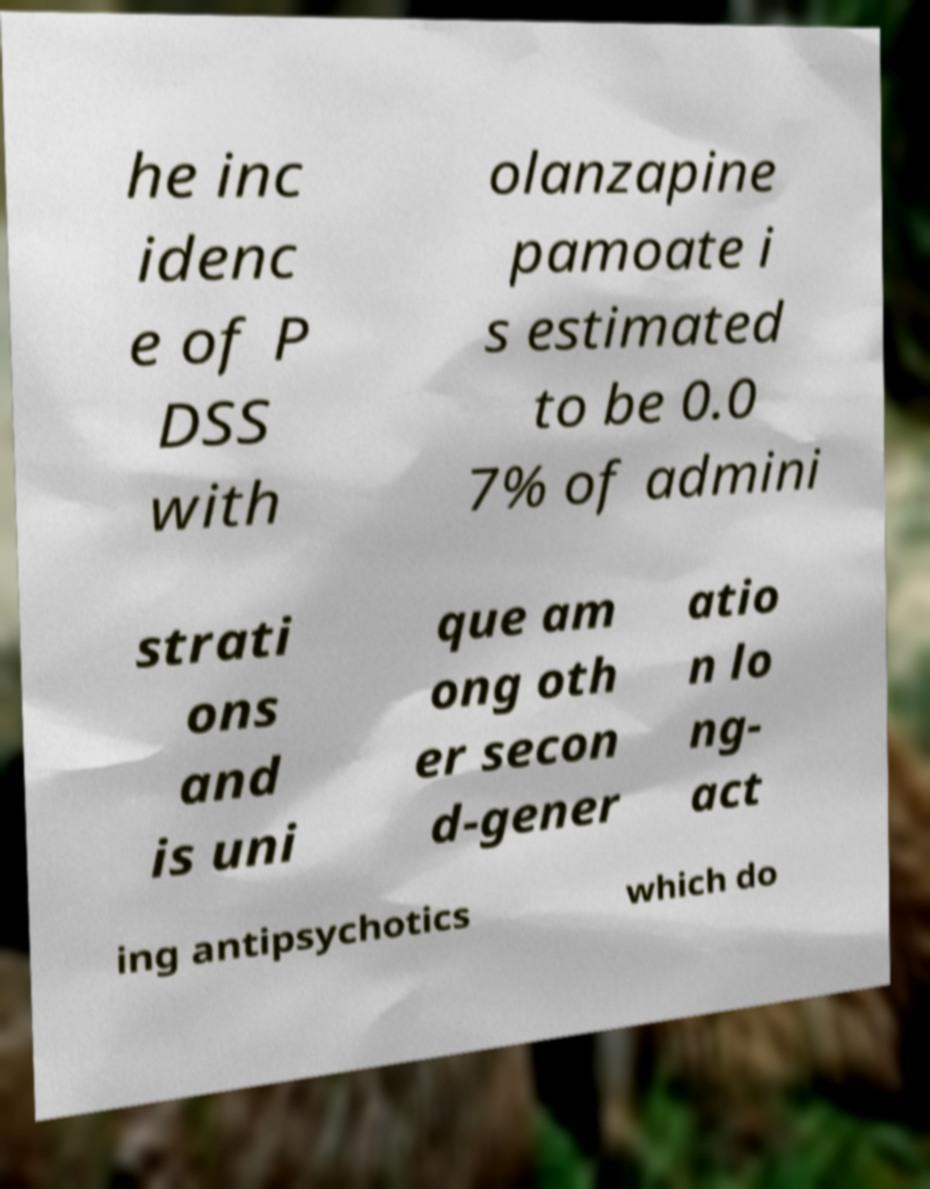Please read and relay the text visible in this image. What does it say? he inc idenc e of P DSS with olanzapine pamoate i s estimated to be 0.0 7% of admini strati ons and is uni que am ong oth er secon d-gener atio n lo ng- act ing antipsychotics which do 